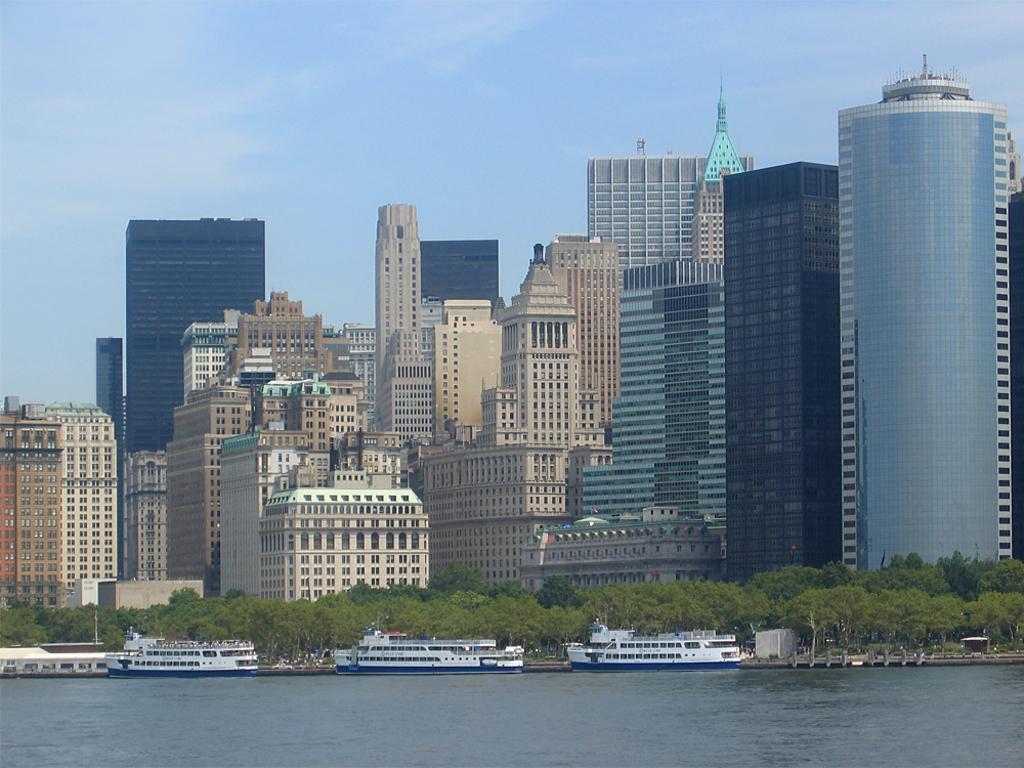Can you describe this image briefly? In this picture I can see there is a river and there are boats sailing, in the backdrop I can see there are trees, buildings and they have glass windows and the sky is clear. 